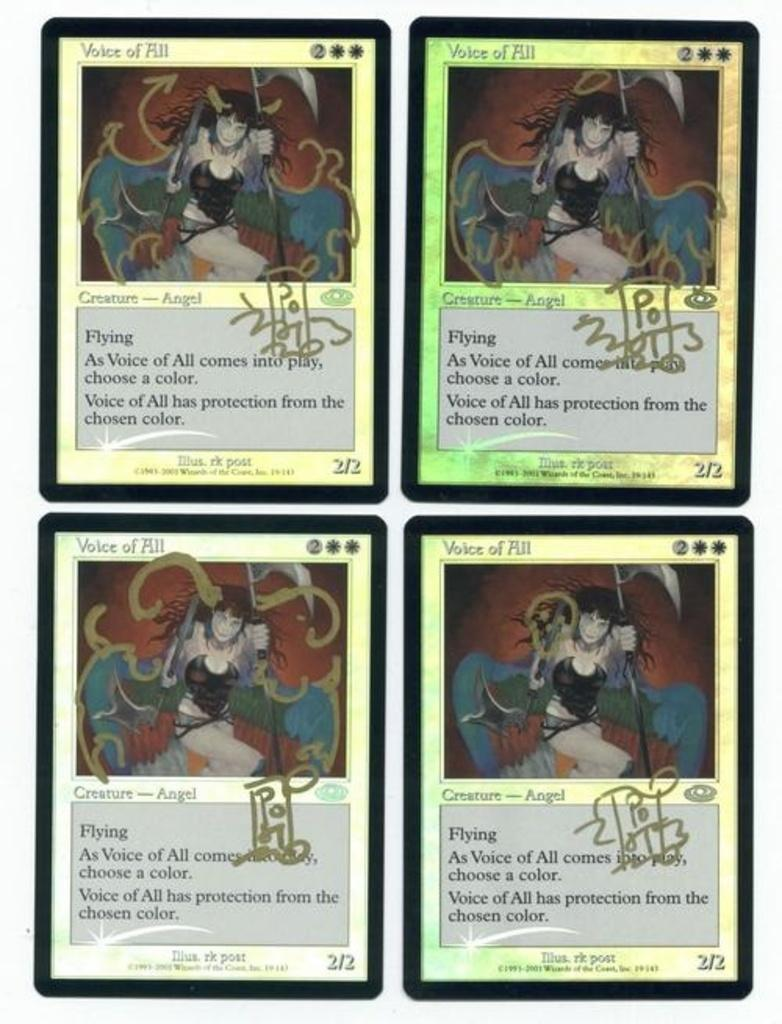What type of artwork is depicted in the image? The image is a collage. What are the main elements of the collage? The collage consists of cards. What type of bushes can be seen growing around the cards in the image? There are no bushes present in the image; it is a collage consisting of cards. What type of brass material is used to create the cards in the image? There is no brass material mentioned in the image; the cards are not described in terms of their composition. 